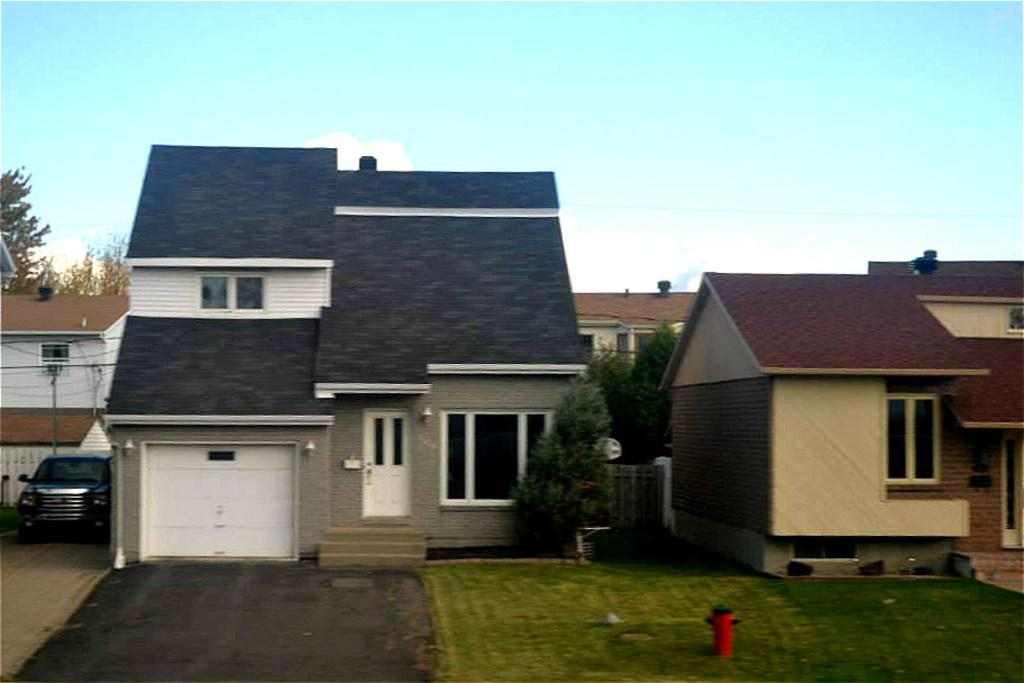What is located in the foreground of the image? There is a fire hydrant in the foreground of the image. What type of vegetation is present in the foreground of the image? Grass and trees are visible in the foreground of the image. What architectural features can be seen in the image? Windows, doors, and houses are visible in the image. What mode of transportation is present in the image? There is a car on the road in the image. What is visible in the background of the image? The sky is visible in the background of the image. When was the image taken? The image was taken during the day. What type of news is being reported by the coat in the image? There is no coat or news present in the image. How does the car stop in the image? The car does not stop in the image; it is moving on the road. 